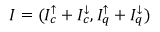Convert formula to latex. <formula><loc_0><loc_0><loc_500><loc_500>I = ( I _ { c } ^ { \uparrow } + I _ { c } ^ { \downarrow } , I _ { q } ^ { \uparrow } + I _ { q } ^ { \downarrow } )</formula> 